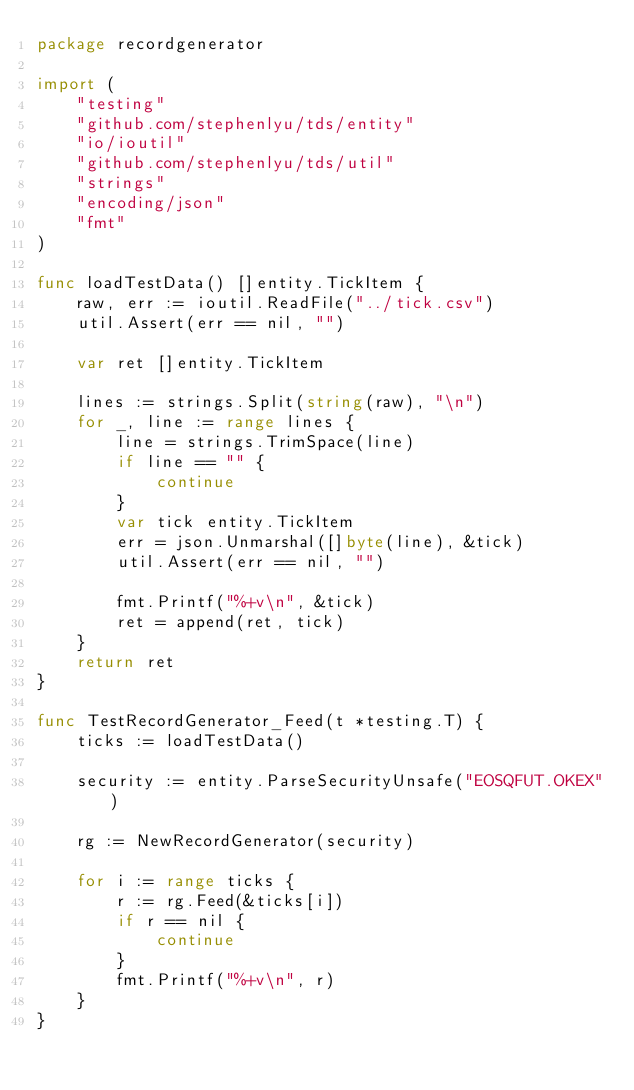<code> <loc_0><loc_0><loc_500><loc_500><_Go_>package recordgenerator

import (
	"testing"
	"github.com/stephenlyu/tds/entity"
	"io/ioutil"
	"github.com/stephenlyu/tds/util"
	"strings"
	"encoding/json"
	"fmt"
)

func loadTestData() []entity.TickItem {
	raw, err := ioutil.ReadFile("../tick.csv")
	util.Assert(err == nil, "")

	var ret []entity.TickItem

	lines := strings.Split(string(raw), "\n")
	for _, line := range lines {
		line = strings.TrimSpace(line)
		if line == "" {
			continue
		}
		var tick entity.TickItem
		err = json.Unmarshal([]byte(line), &tick)
		util.Assert(err == nil, "")

		fmt.Printf("%+v\n", &tick)
		ret = append(ret, tick)
	}
	return ret
}

func TestRecordGenerator_Feed(t *testing.T) {
	ticks := loadTestData()

	security := entity.ParseSecurityUnsafe("EOSQFUT.OKEX")

	rg := NewRecordGenerator(security)

	for i := range ticks {
		r := rg.Feed(&ticks[i])
		if r == nil {
			continue
		}
		fmt.Printf("%+v\n", r)
	}
}
</code> 